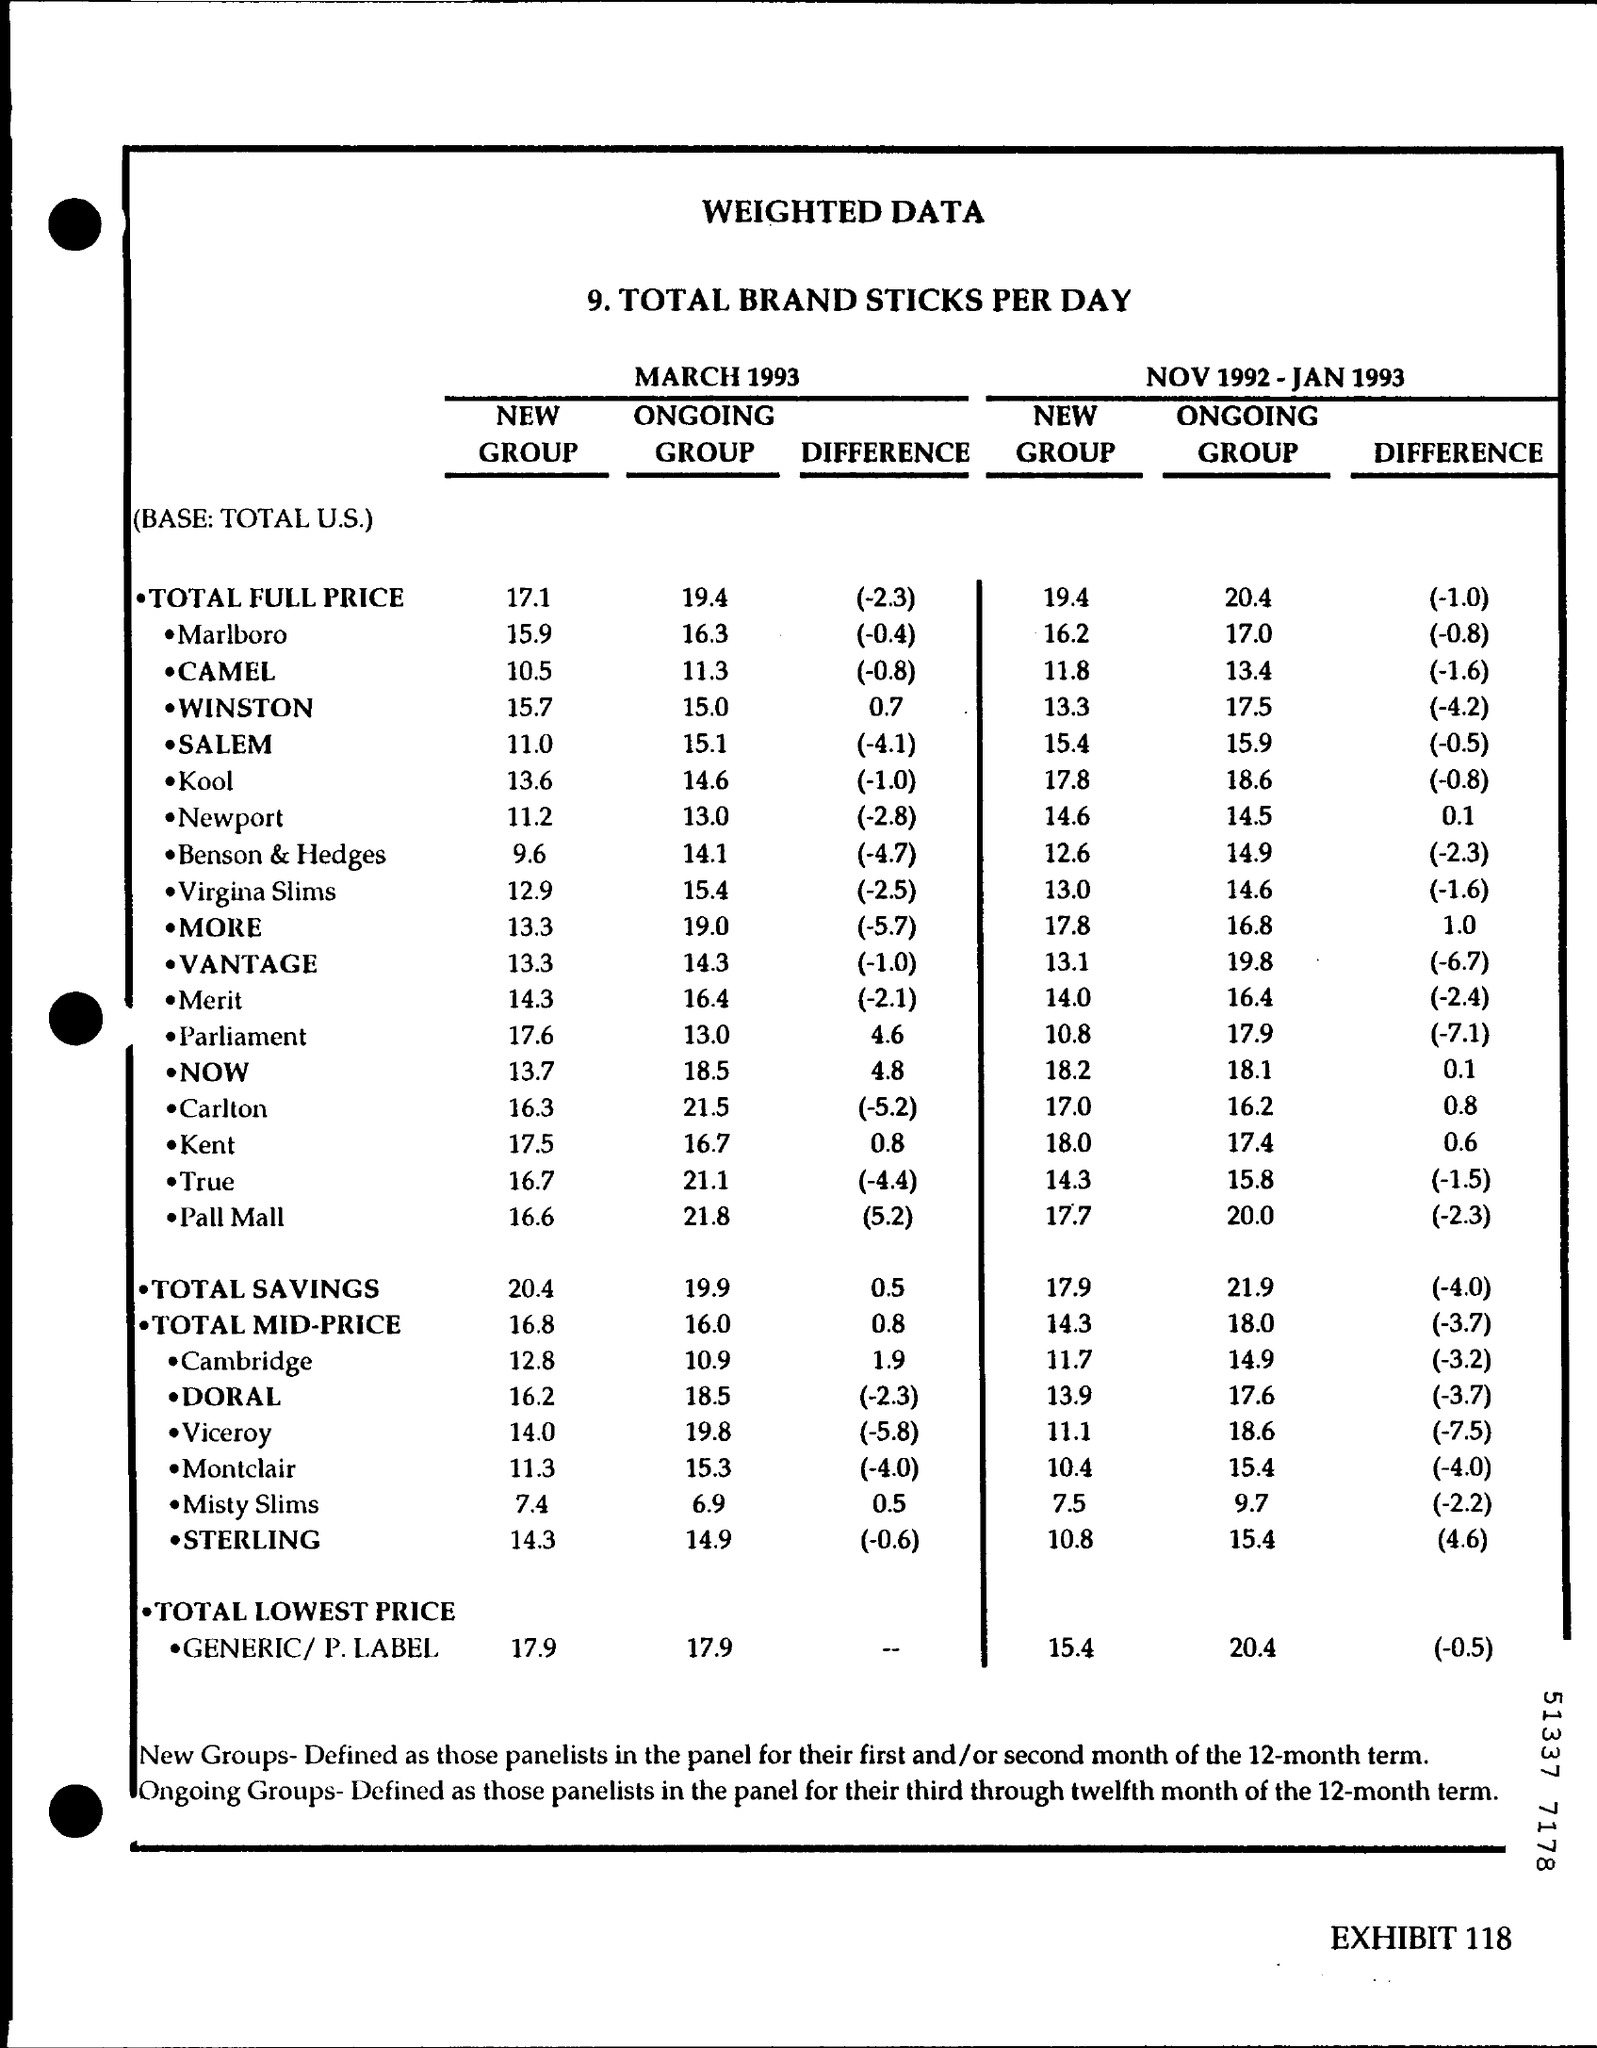Specify some key components in this picture. The total savings for the new group for March 1993 was 20.4. The total savings for the ongoing group during the period of NOV 1992 to JAN 1993 was 21.9. The total savings for the ongoing group in March 1993 was $19.90. The total mid-price for the new group for the period of November 1992 to January 1993 was 14.3. The total savings for the new group for the period of NOV 1992 to JAN 1993 was 17.9%. 